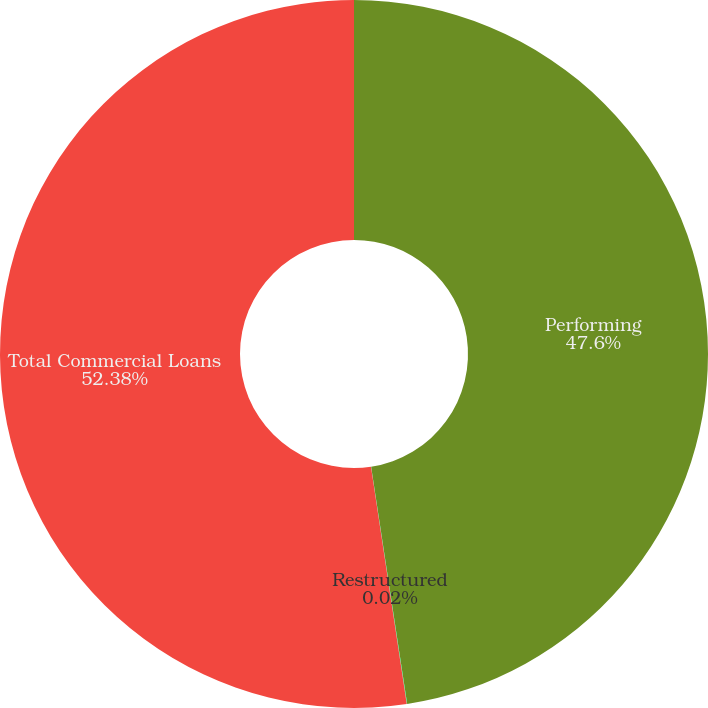<chart> <loc_0><loc_0><loc_500><loc_500><pie_chart><fcel>Performing<fcel>Restructured<fcel>Total Commercial Loans<nl><fcel>47.6%<fcel>0.02%<fcel>52.38%<nl></chart> 